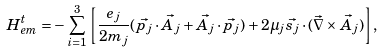<formula> <loc_0><loc_0><loc_500><loc_500>H ^ { t } _ { e m } = - \sum _ { i = 1 } ^ { 3 } \left [ \frac { e _ { j } } { 2 m _ { j } } ( \vec { p _ { j } } \cdot \vec { A _ { j } } + \vec { A _ { j } } \cdot \vec { p _ { j } } ) + 2 \mu _ { j } \vec { s _ { j } } \cdot ( \vec { \nabla } \times \vec { A _ { j } } ) \right ] ,</formula> 